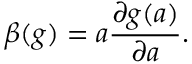<formula> <loc_0><loc_0><loc_500><loc_500>\beta ( g ) = a \frac { \partial g ( a ) } { \partial a } .</formula> 